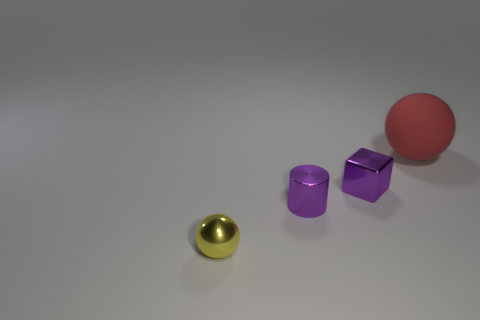There is a block that is the same size as the yellow thing; what material is it? The block that matches the size of the yellow object appears to be made of a metallic material, likely showing a matte-finish metal which contrasts with the metallic sheen of the yellow object. 